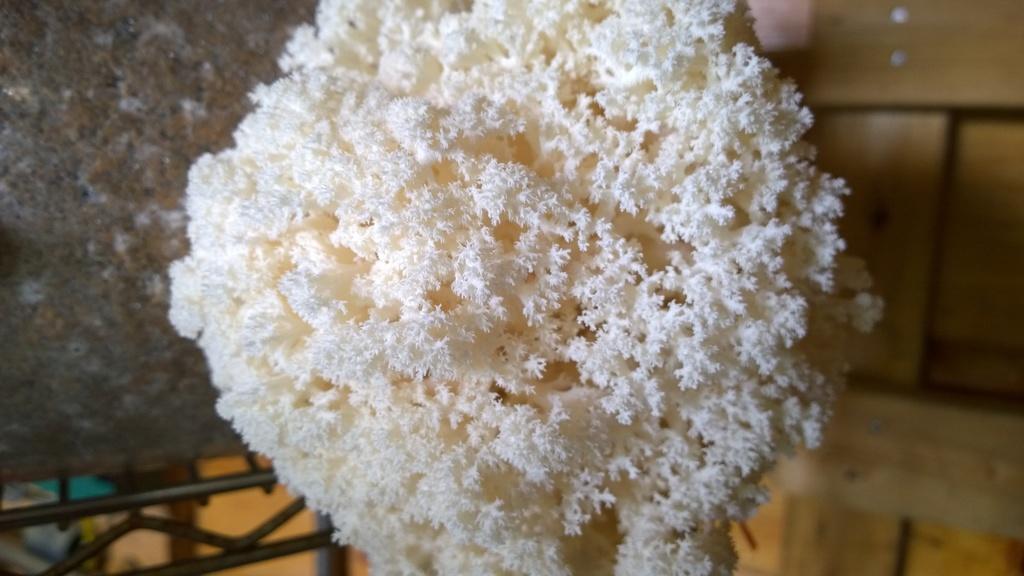Could you give a brief overview of what you see in this image? In this picture there is an object which is in white in color. 